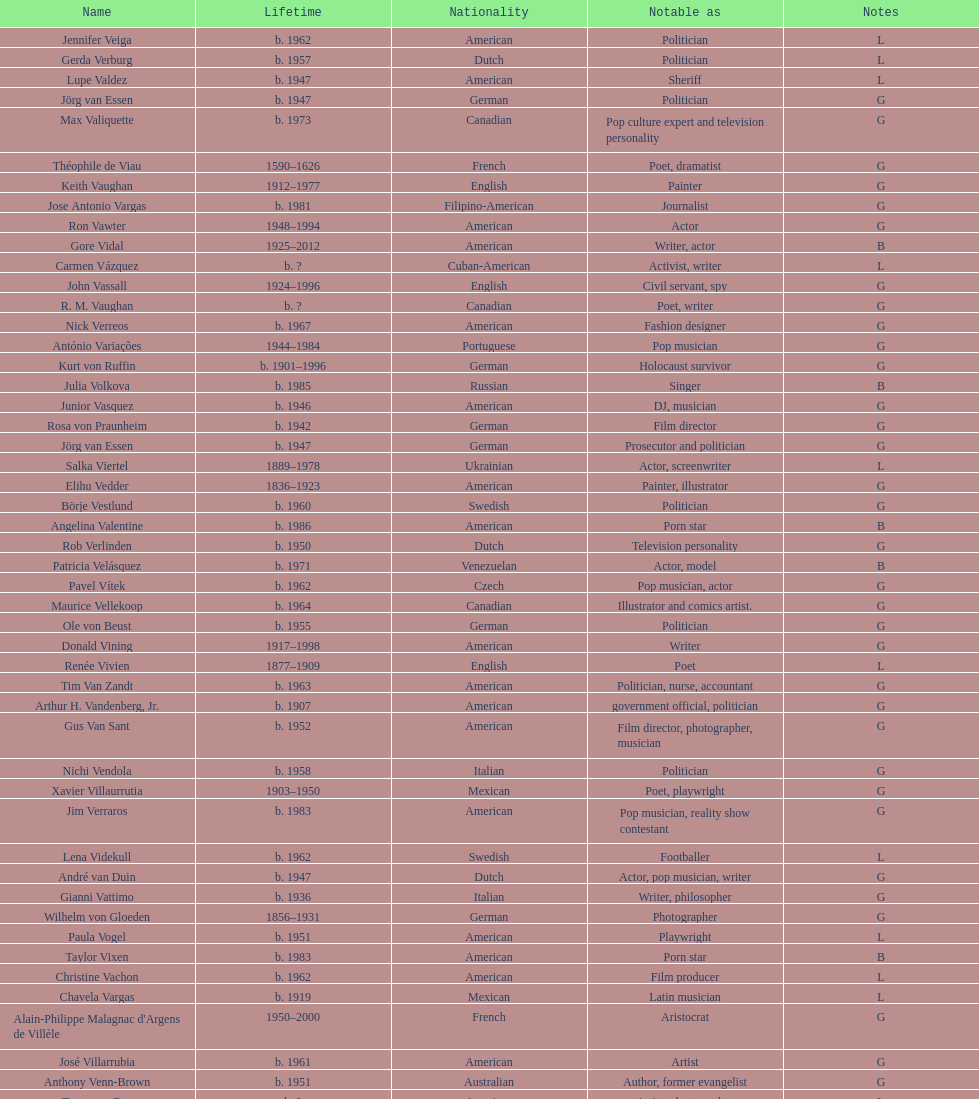How old was pierre vallieres before he died? 60. 